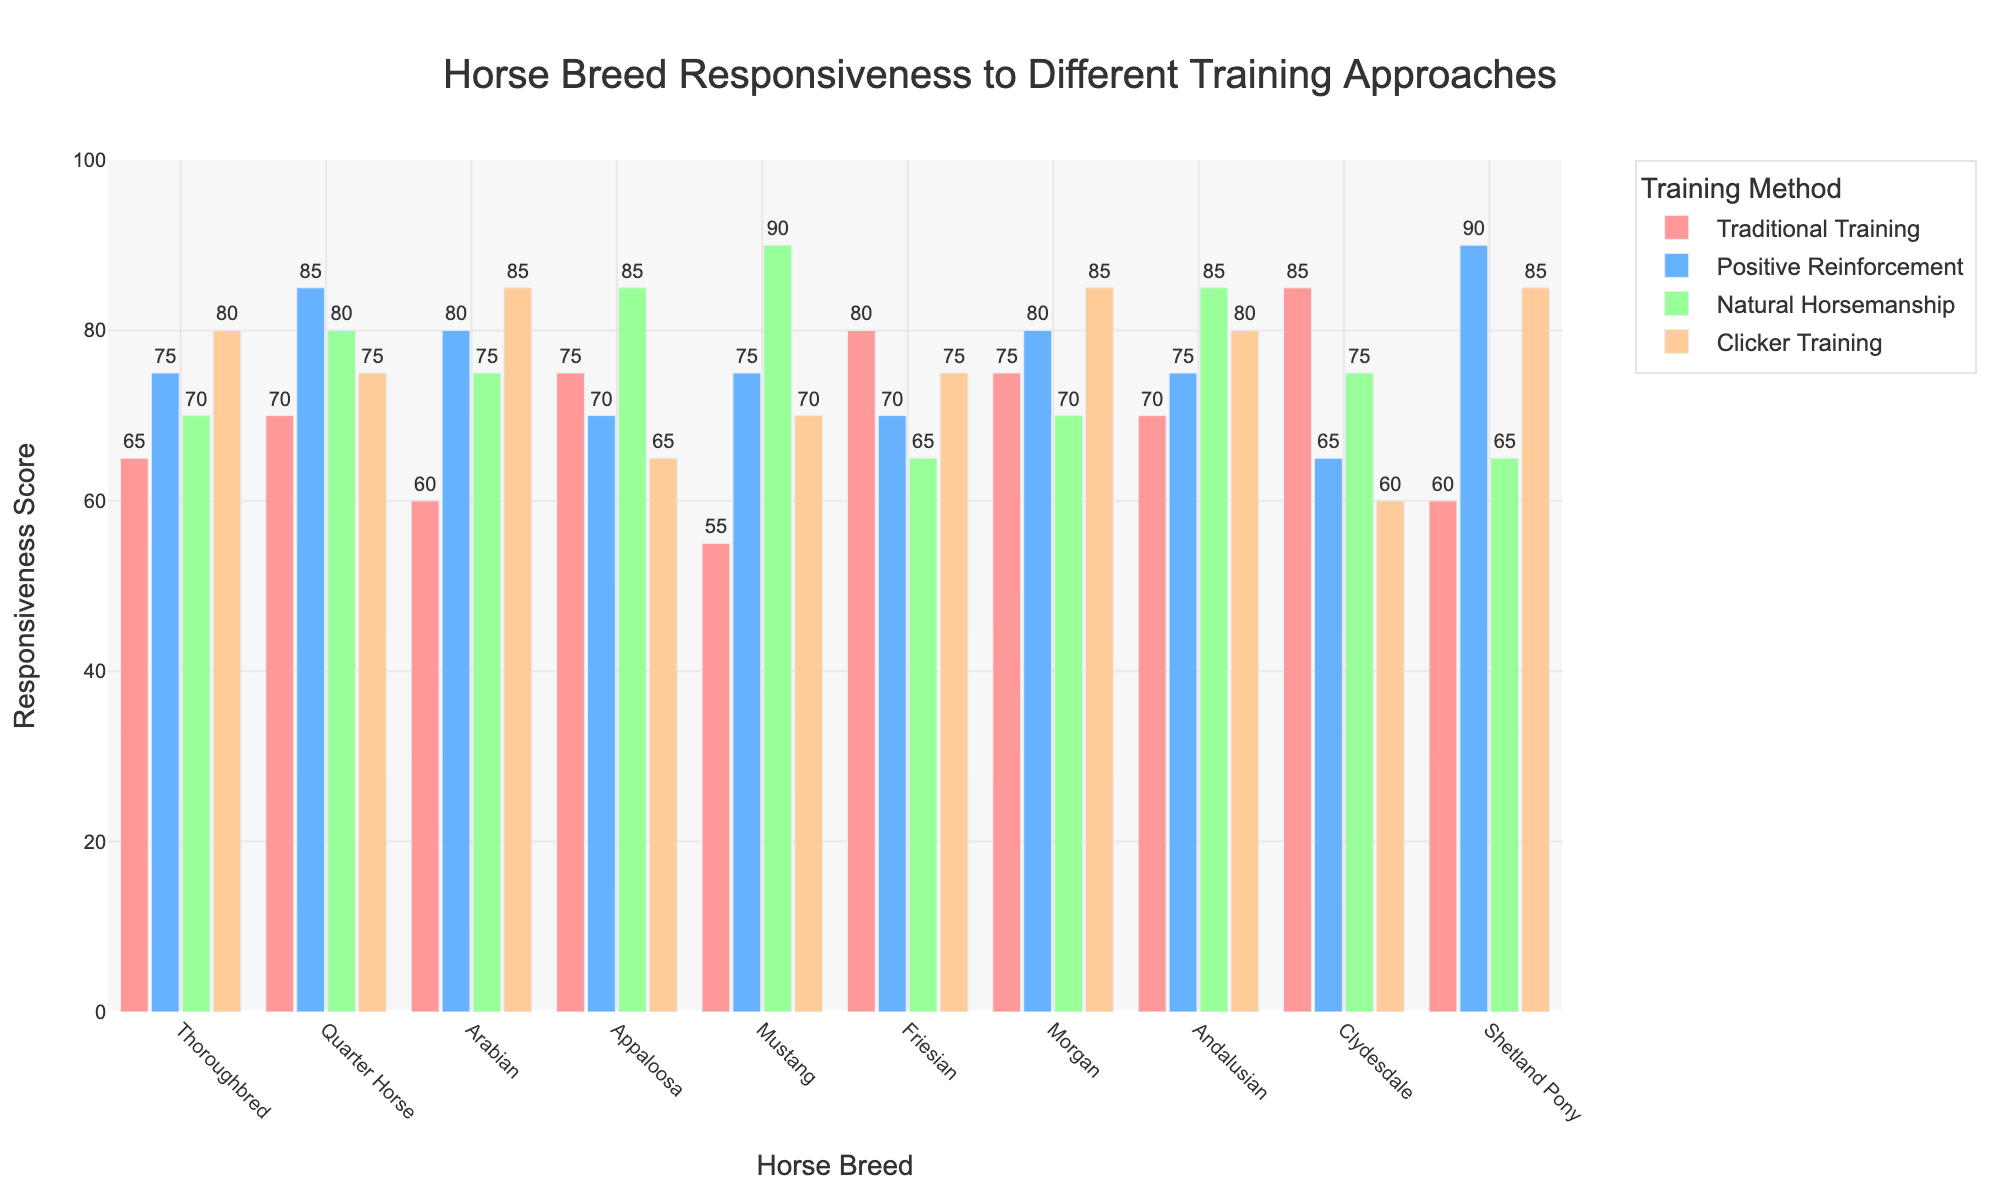Which breed is most responsive to Clicker Training? Observe the height of the bars representing Clicker Training (the light orange bars) and find the tallest one. Shetland Pony has the tallest bar.
Answer: Shetland Pony Which breed has the least responsiveness to Traditional Training? Observe the height of the bars representing Traditional Training (the light red bars) and identify the shortest one. Mustang has the shortest bar.
Answer: Mustang Which training method has the highest responsiveness score for Arabians? Look at the four bars representing responsiveness scores for Arabians and identify the tallest bar. Clicker Training has the highest value.
Answer: Clicker Training Compare the responsiveness of Friesians to Traditional Training and Clicker Training. Which one is higher? Check the height of the bars for Friesians under Traditional Training and Clicker Training. Traditional Training is higher.
Answer: Traditional Training For the Mustangs, which training approach shows the greatest difference in responsiveness compared to Positive Reinforcement? Calculate the differences between Mustang's score for Positive Reinforcement and each of the other approaches: Traditional Training (75-55=20), Natural Horsemanship (90-75=15), Clicker Training (75-70=5). The greatest difference is with Traditional Training.
Answer: Traditional Training What is the average responsiveness score for the Quarter Horse across all training methods? Add the responsiveness scores for Quarter Horse: (70 + 85 + 80 + 75) = 310. Divide by the number of methods, which is 4. The average is 310/4 = 77.5.
Answer: 77.5 Which breed shows the greatest variability in responsiveness scores across the four training methods? Calculate the range (max - min) of scores for each breed to find the greatest variability. Thoroughbred: 80-65=15, Quarter Horse: 85-70=15, Arabian: 85-60=25, Appaloosa: 85-65=20, Mustang: 90-55=35, Friesian: 80-65=15, Morgan: 85-70=15, Andalusian: 85-70=15, Clydesdale: 85-60=25, Shetland Pony: 90-60=30. Greatest is Mustang with 35.
Answer: Mustang Which training method has the most consistent responsiveness scores across all breeds? Calculate the range (max - min) of scores for each training method. Traditional Training: 85-55=30, Positive Reinforcement: 90-65=25, Natural Horsemanship: 90-65=25, Clicker Training: 85-60=25. The most consistent is Clicker Training with a range of 25.
Answer: Clicker Training If combining Natural Horsemanship and Clicker Training, which breed has the highest combined responsiveness score? Sum the scores of both methods for each breed to find the highest combined score. Thoroughbred: 70+80=150, Quarter Horse: 80+75=155, Arabian: 75+85=160, Appaloosa: 85+65=150, Mustang: 90+70=160, Friesian: 65+75=140, Morgan: 70+85=155, Andalusian: 85+80=165, Clydesdale: 75+60=135, Shetland Pony: 65+85=150. Andalusian has the highest combined score of 165.
Answer: Andalusian 